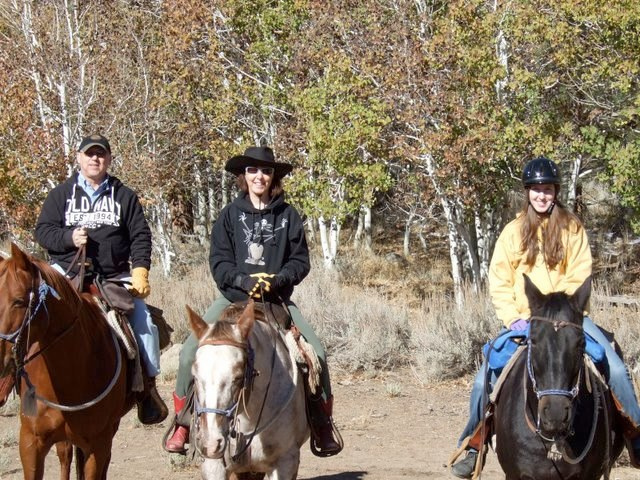What is the name of a person who rides these animals in races?
Answer the question using a single word or phrase. Jockey 